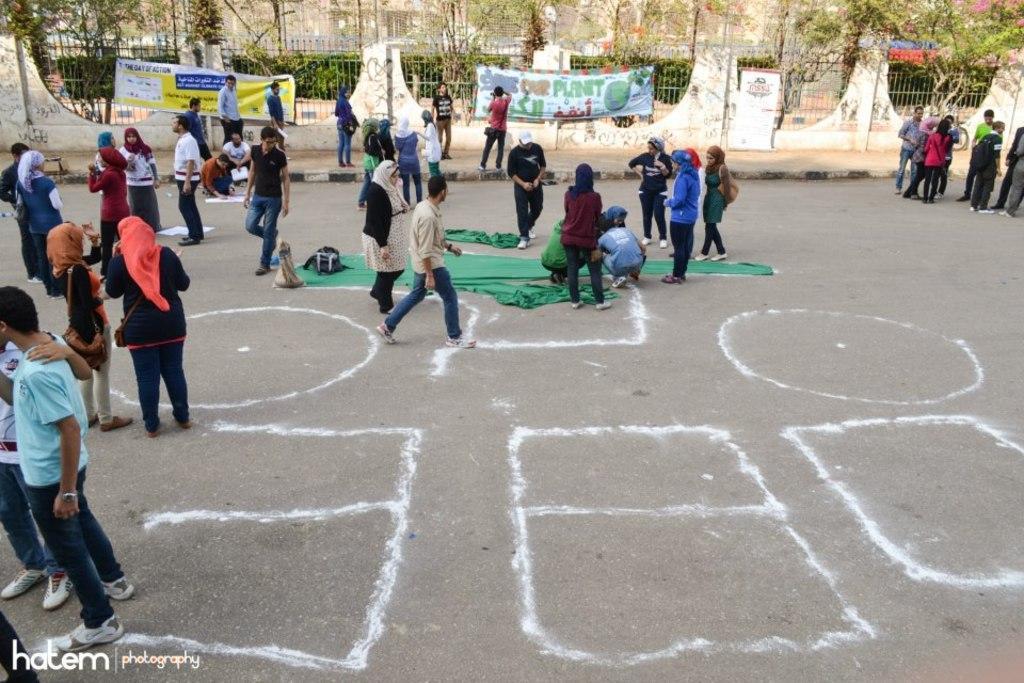In one or two sentences, can you explain what this image depicts? In the center of the image we can see a few people are standing and few people are holding some objects. And we can see a few people are wearing scarves and a few other objects. And we can see green curtains, bags and a few other objects. In the background we can see trees, fences, banners, few people are standing and a few other objects. 